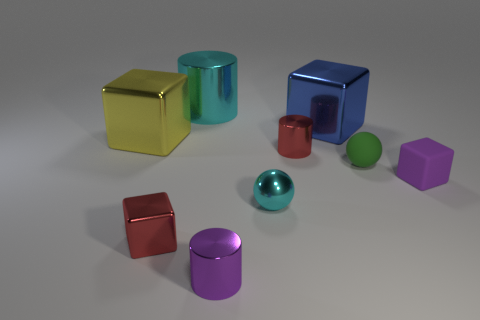Is the big shiny cylinder the same color as the tiny metal ball?
Make the answer very short. Yes. There is a cyan metallic object that is behind the green ball; does it have the same size as the large blue metal cube?
Make the answer very short. Yes. What number of tiny objects are red metallic spheres or rubber spheres?
Ensure brevity in your answer.  1. Is there a small matte sphere that has the same color as the large metal cylinder?
Make the answer very short. No. There is a yellow object that is the same size as the blue shiny thing; what shape is it?
Offer a very short reply. Cube. Is the color of the tiny block on the left side of the rubber ball the same as the large metal cylinder?
Keep it short and to the point. No. How many things are either yellow things in front of the large cyan cylinder or small yellow blocks?
Your answer should be very brief. 1. Is the number of large blue cubes on the left side of the large yellow metal object greater than the number of tiny green rubber objects that are on the left side of the big cyan thing?
Your answer should be very brief. No. Is the small purple cube made of the same material as the tiny cyan thing?
Your answer should be very brief. No. What is the shape of the tiny thing that is to the left of the small purple matte block and to the right of the big blue metal thing?
Provide a short and direct response. Sphere. 